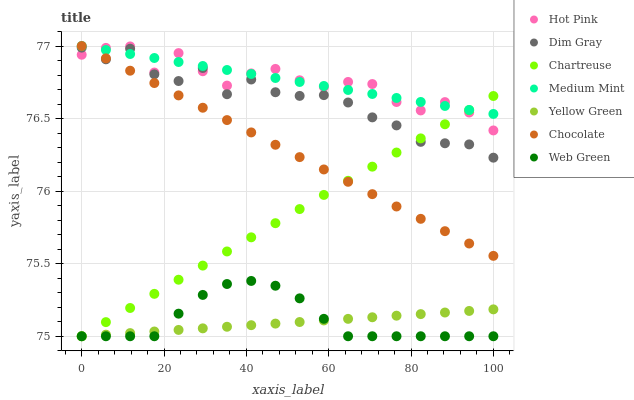Does Yellow Green have the minimum area under the curve?
Answer yes or no. Yes. Does Medium Mint have the maximum area under the curve?
Answer yes or no. Yes. Does Dim Gray have the minimum area under the curve?
Answer yes or no. No. Does Dim Gray have the maximum area under the curve?
Answer yes or no. No. Is Chocolate the smoothest?
Answer yes or no. Yes. Is Dim Gray the roughest?
Answer yes or no. Yes. Is Yellow Green the smoothest?
Answer yes or no. No. Is Yellow Green the roughest?
Answer yes or no. No. Does Yellow Green have the lowest value?
Answer yes or no. Yes. Does Dim Gray have the lowest value?
Answer yes or no. No. Does Chocolate have the highest value?
Answer yes or no. Yes. Does Dim Gray have the highest value?
Answer yes or no. No. Is Yellow Green less than Hot Pink?
Answer yes or no. Yes. Is Dim Gray greater than Web Green?
Answer yes or no. Yes. Does Medium Mint intersect Chocolate?
Answer yes or no. Yes. Is Medium Mint less than Chocolate?
Answer yes or no. No. Is Medium Mint greater than Chocolate?
Answer yes or no. No. Does Yellow Green intersect Hot Pink?
Answer yes or no. No. 